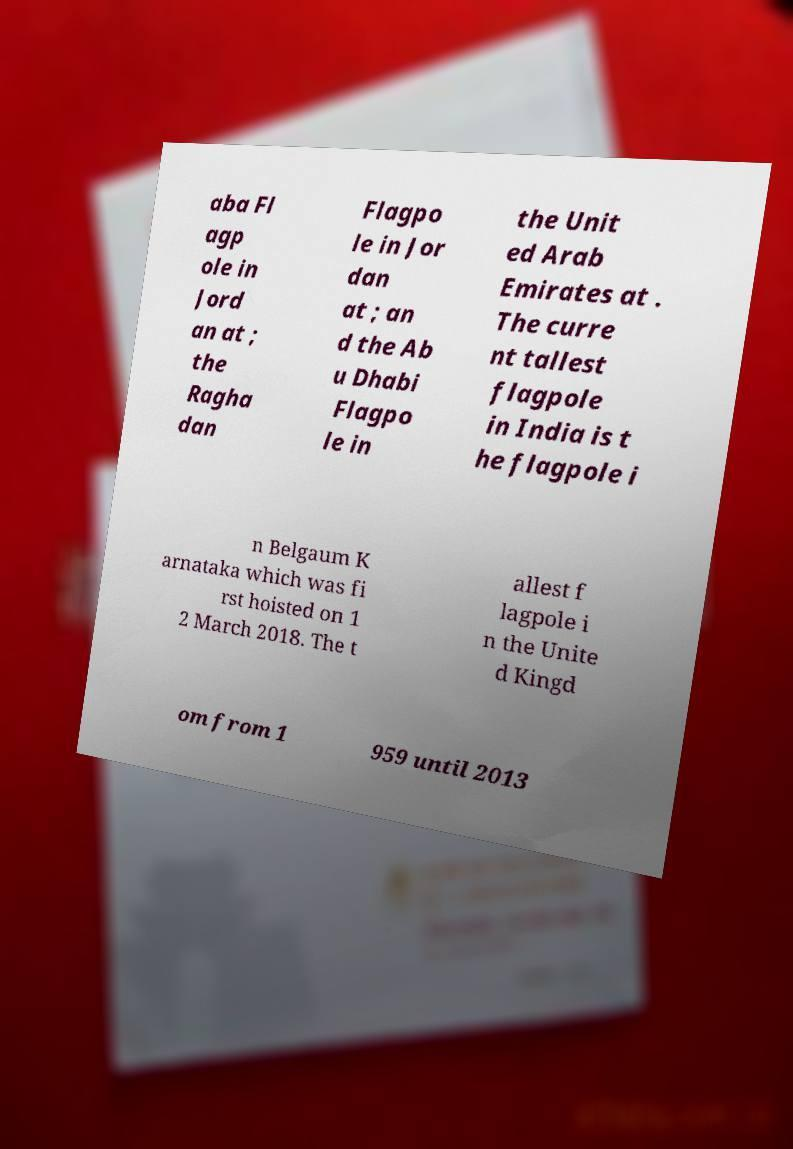What messages or text are displayed in this image? I need them in a readable, typed format. aba Fl agp ole in Jord an at ; the Ragha dan Flagpo le in Jor dan at ; an d the Ab u Dhabi Flagpo le in the Unit ed Arab Emirates at . The curre nt tallest flagpole in India is t he flagpole i n Belgaum K arnataka which was fi rst hoisted on 1 2 March 2018. The t allest f lagpole i n the Unite d Kingd om from 1 959 until 2013 